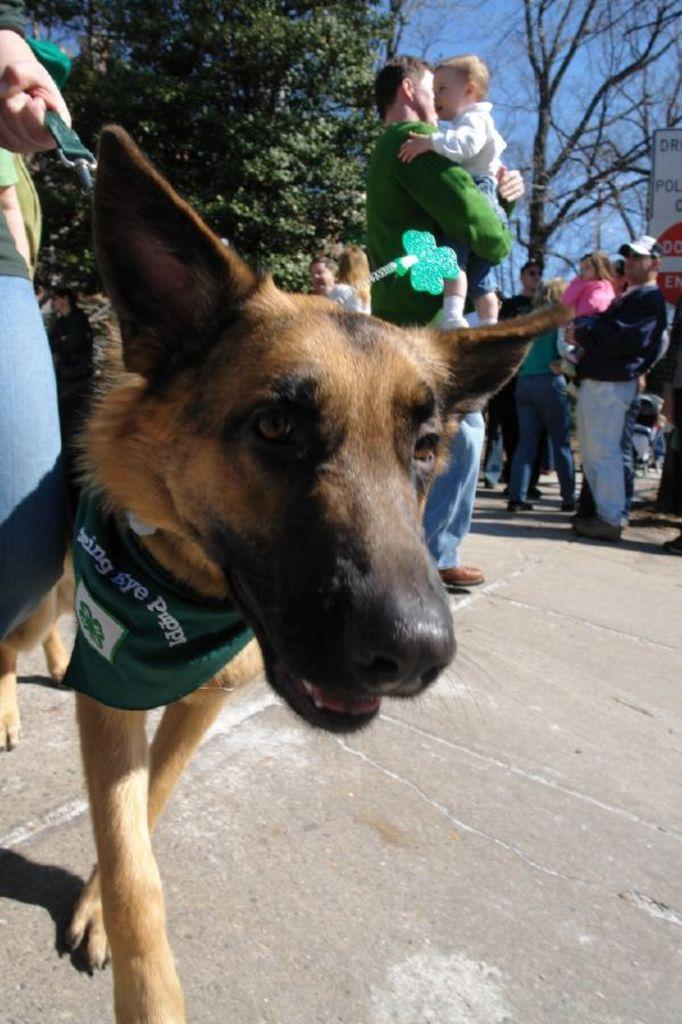What type of animal can be seen in the image? There is a brown dog in the image. What can be seen in the background of the image? There are trees in the distance. What are the people in the image doing? There are persons standing in the image, and two of them are carrying a baby. What type of veil is being worn by the dog in the image? There is no veil present in the image, as it features a brown dog and people. Can you tell me how many ants are visible in the image? There are no ants present in the image. 